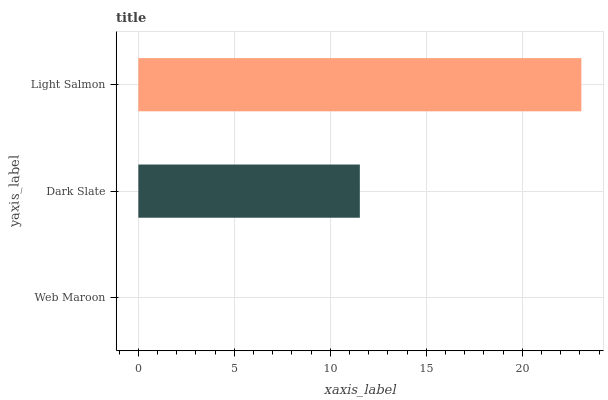Is Web Maroon the minimum?
Answer yes or no. Yes. Is Light Salmon the maximum?
Answer yes or no. Yes. Is Dark Slate the minimum?
Answer yes or no. No. Is Dark Slate the maximum?
Answer yes or no. No. Is Dark Slate greater than Web Maroon?
Answer yes or no. Yes. Is Web Maroon less than Dark Slate?
Answer yes or no. Yes. Is Web Maroon greater than Dark Slate?
Answer yes or no. No. Is Dark Slate less than Web Maroon?
Answer yes or no. No. Is Dark Slate the high median?
Answer yes or no. Yes. Is Dark Slate the low median?
Answer yes or no. Yes. Is Light Salmon the high median?
Answer yes or no. No. Is Light Salmon the low median?
Answer yes or no. No. 